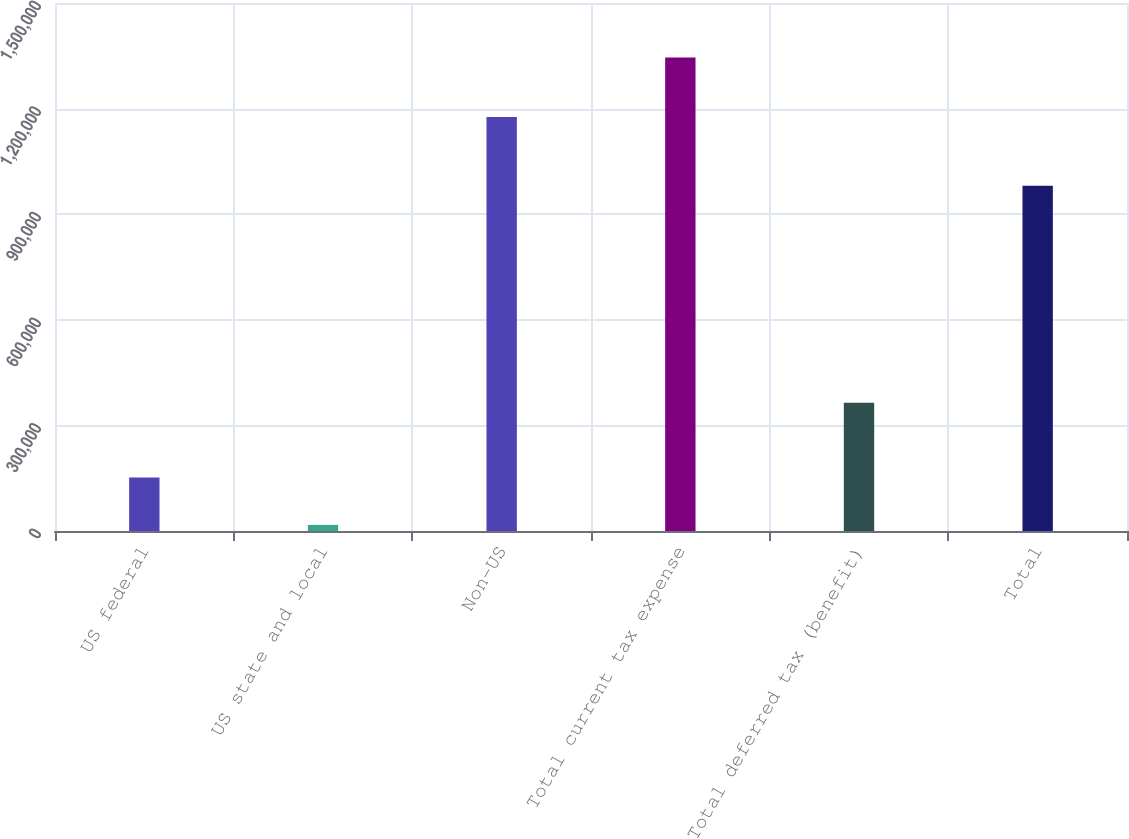<chart> <loc_0><loc_0><loc_500><loc_500><bar_chart><fcel>US federal<fcel>US state and local<fcel>Non-US<fcel>Total current tax expense<fcel>Total deferred tax (benefit)<fcel>Total<nl><fcel>152002<fcel>17269<fcel>1.17596e+06<fcel>1.34523e+06<fcel>364133<fcel>981100<nl></chart> 